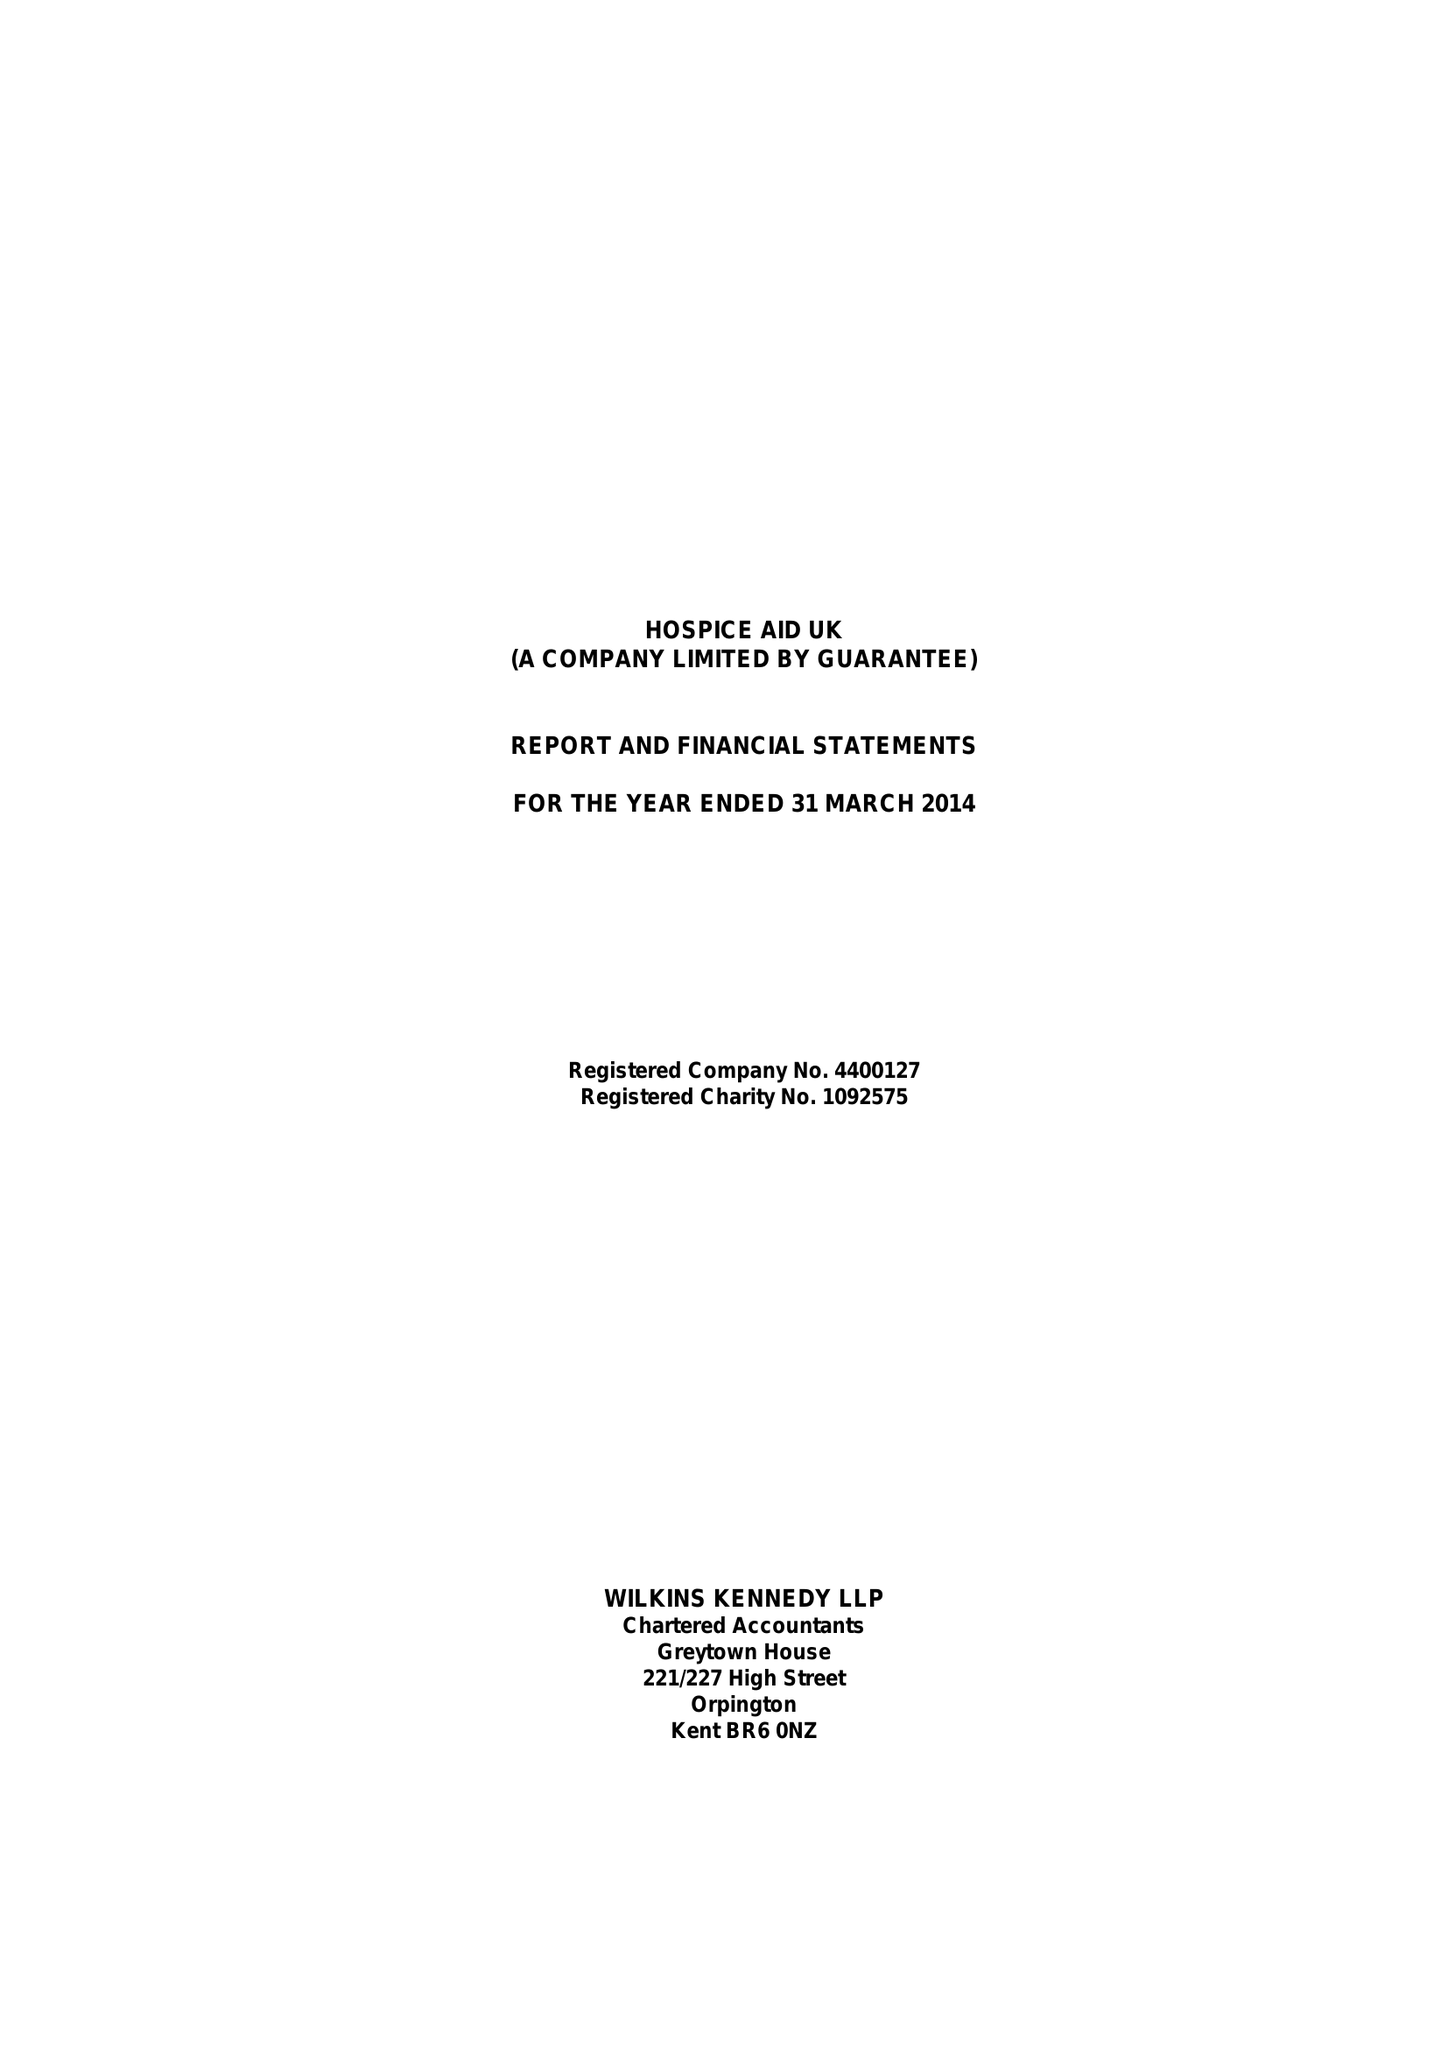What is the value for the report_date?
Answer the question using a single word or phrase. 2014-03-31 